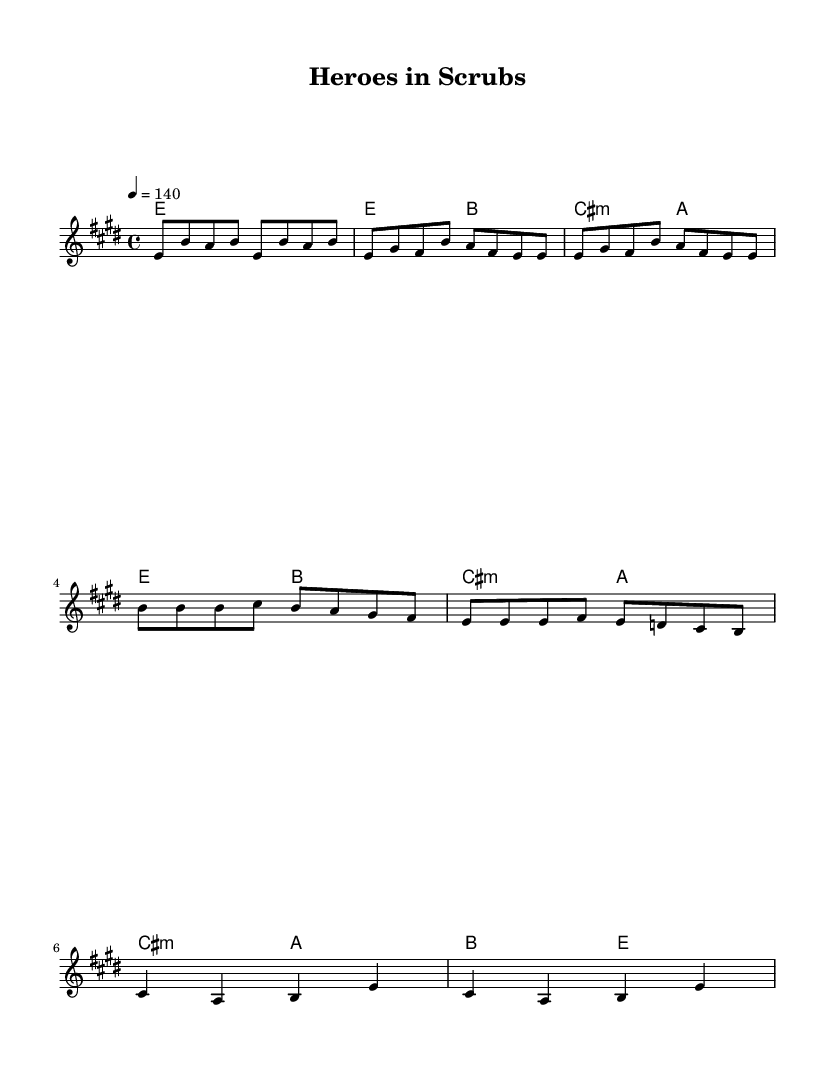What is the key signature of this music? The key signature is E major, which has four sharps: F#, C#, G#, and D#. This can be determined by looking at the key signature indicated at the beginning of the score.
Answer: E major What is the time signature of this music? The time signature is 4/4, which is indicated at the beginning of the score. This means there are four beats per measure and the quarter note receives one beat.
Answer: 4/4 What is the tempo marking of this music? The tempo marking is 4 equals 140, which is a metronome marking indicating that the quarter note should be played at 140 beats per minute. This is found near the top of the score next to the word "tempo."
Answer: 140 How many measures are there in the chorus section? The chorus is composed of two measures, as indicated by counting the notated bars in the chorus section of the score, where the melody and harmony align with the lyric section.
Answer: 2 What is the musical form of this piece? The musical form is verse-chorus form, as the piece alternates between verses and a chorus, a common structure in rock music. This can be inferred from the division of the music into distinct sections labeled as the verse and chorus.
Answer: Verse-chorus How many times does the word "heroes" appear in the lyrics? The word "heroes" appears two times in the lyrics of the chorus section. By reading the text aligned with the melody and counting instances of "heroes," we identify its total occurrences.
Answer: 2 What type of harmony is primarily used in the song? The song primarily uses major and minor chords, as seen in the chord names listed (E, B, C# minor, A). This reflects the typical harmonic structure in rock anthems, characterized by major-minor tonality.
Answer: Major and minor 